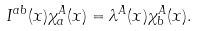Convert formula to latex. <formula><loc_0><loc_0><loc_500><loc_500>I ^ { a b } ( x ) \chi _ { a } ^ { A } ( x ) = \lambda ^ { A } ( x ) \chi _ { b } ^ { A } ( x ) .</formula> 